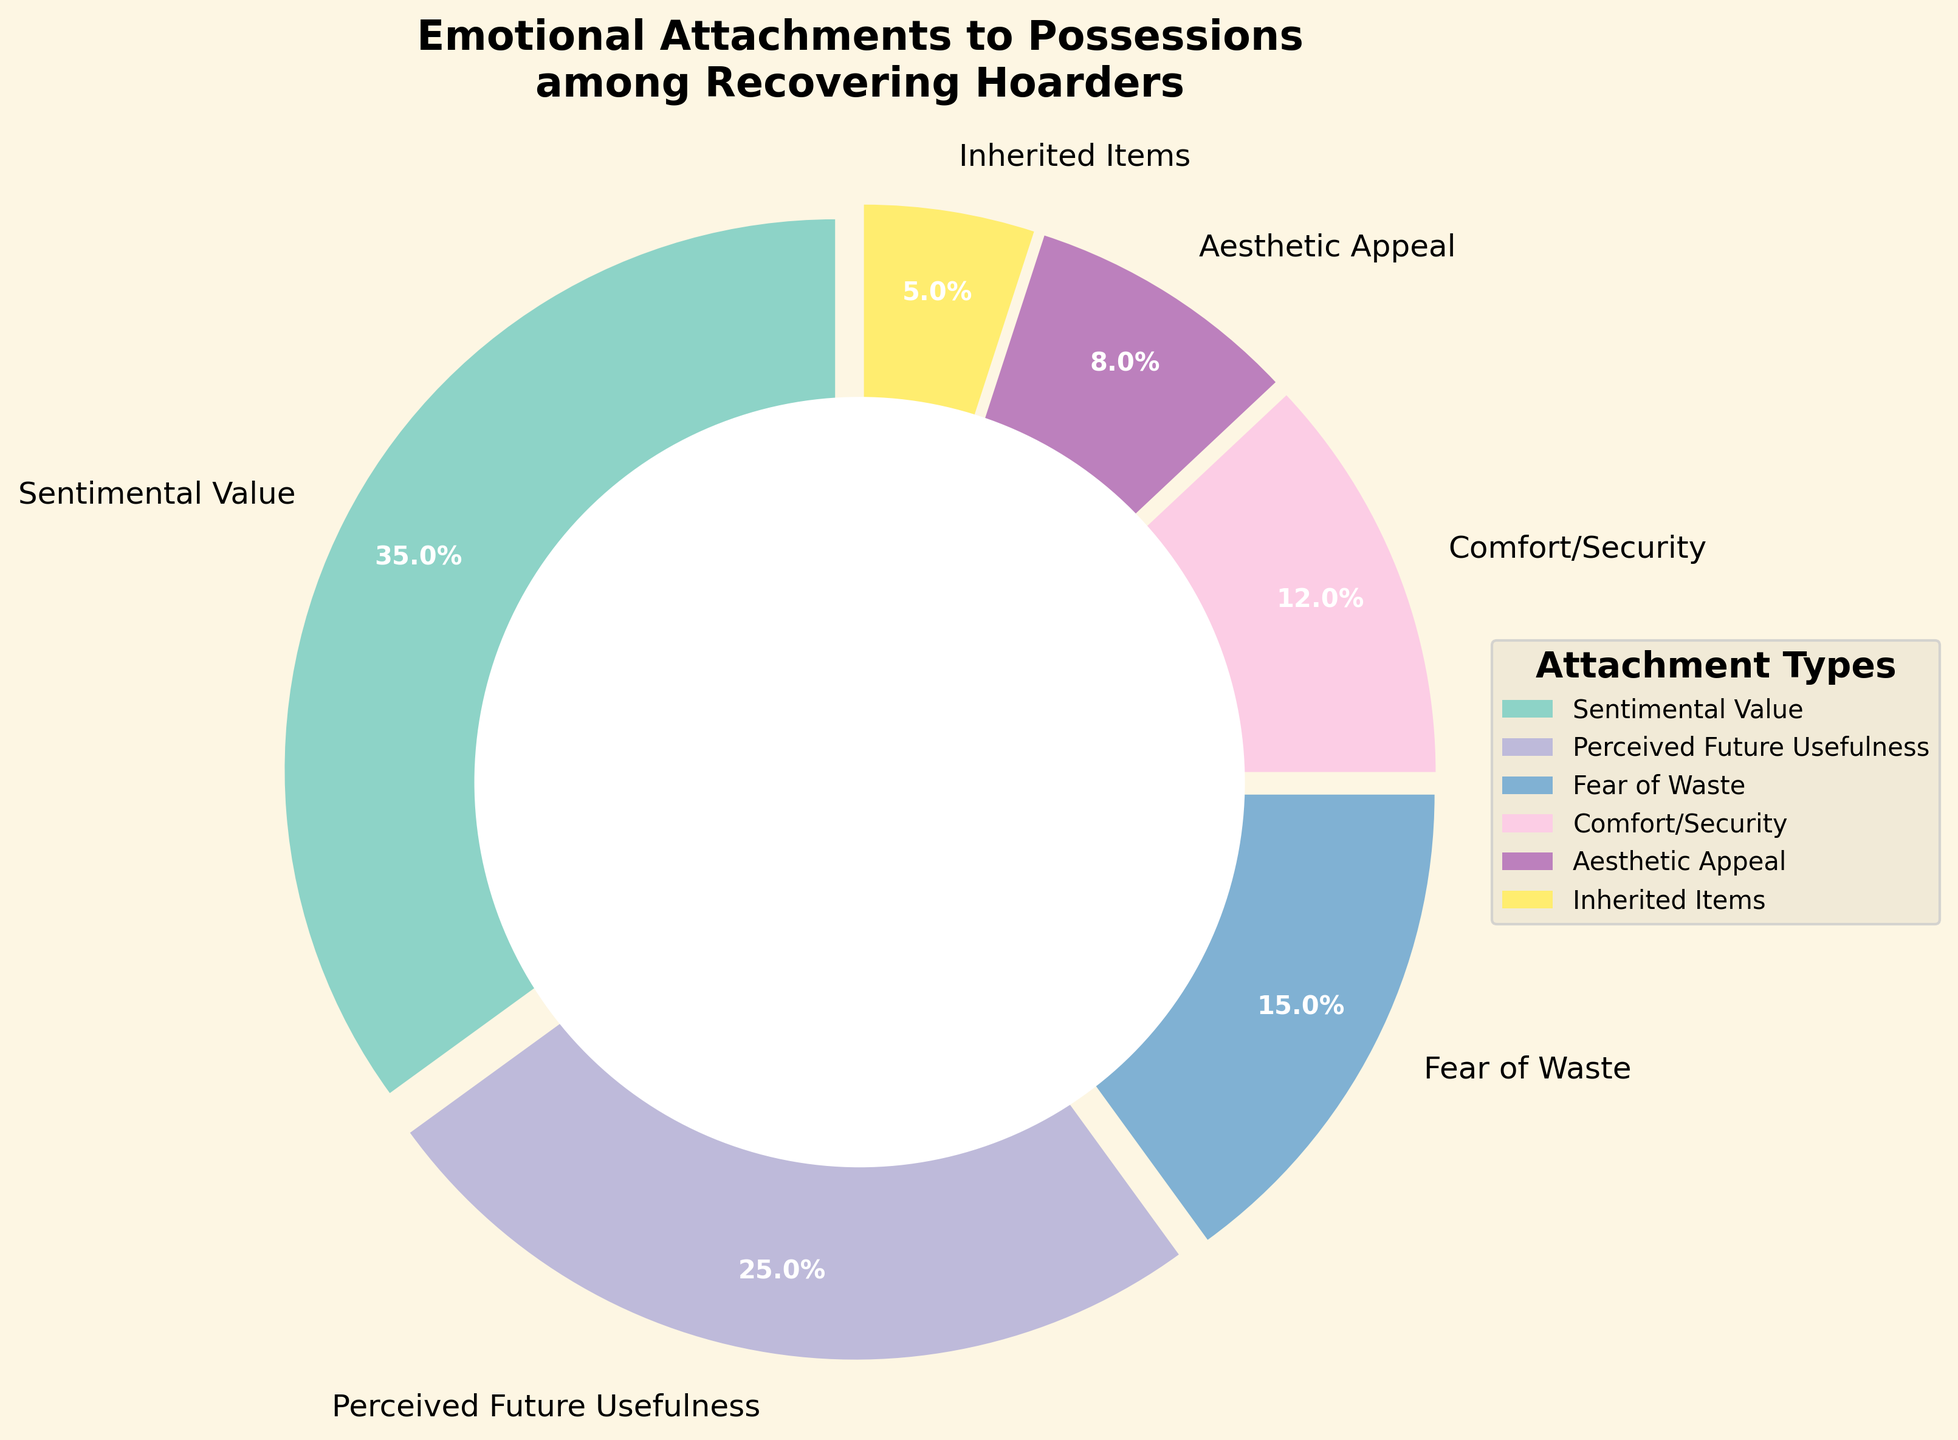What type of emotional attachment has the highest percentage among recovering hoarders? The figure shows different emotional attachments with their respective percentages. By identifying the largest segment, we find that 'Sentimental Value' has the highest percentage of 35%.
Answer: Sentimental Value What is the combined percentage of 'Comfort/Security' and 'Inherited Items'? By adding the percentages of 'Comfort/Security' (12%) and 'Inherited Items' (5%), we get 12% + 5% = 17%.
Answer: 17% Which attachment type has a lower percentage than 'Fear of Waste' but higher than 'Inherited Items'? From the figure, 'Fear of Waste' has 15% and 'Inherited Items' has 5%. The attachment type with a percentage between these two values is 'Comfort/Security' at 12%.
Answer: Comfort/Security Which two attachment types have the smallest percentages? By observing the figure, the two smallest segments correspond to 'Inherited Items' (5%) and 'Aesthetic Appeal' (8%).
Answer: Inherited Items and Aesthetic Appeal How much more percentage does 'Sentimental Value' account for compared to 'Perceived Future Usefulness'? ‘Sentimental Value’ is at 35%, and ‘Perceived Future Usefulness’ is at 25%. The difference is 35% - 25% = 10%.
Answer: 10% What percentage do 'Perceived Future Usefulness' and 'Aesthetic Appeal' account for together? Adding the percentages of 'Perceived Future Usefulness' (25%) and 'Aesthetic Appeal' (8%) results in 25% + 8% = 33%.
Answer: 33% Out of the listed attachment types, which one is associated with the least percentage? According to the figure, 'Inherited Items' has the smallest percentage of all the attachment types at 5%.
Answer: Inherited Items If you were to group 'Fear of Waste' and 'Comfort/Security', how does their combined percentage compare with 'Sentimental Value'? Combining 'Fear of Waste' (15%) and 'Comfort/Security' (12%) gives 15% + 12% = 27%. 'Sentimental Value' is at 35%. Comparing the two, 27% is less than 35%.
Answer: Less 